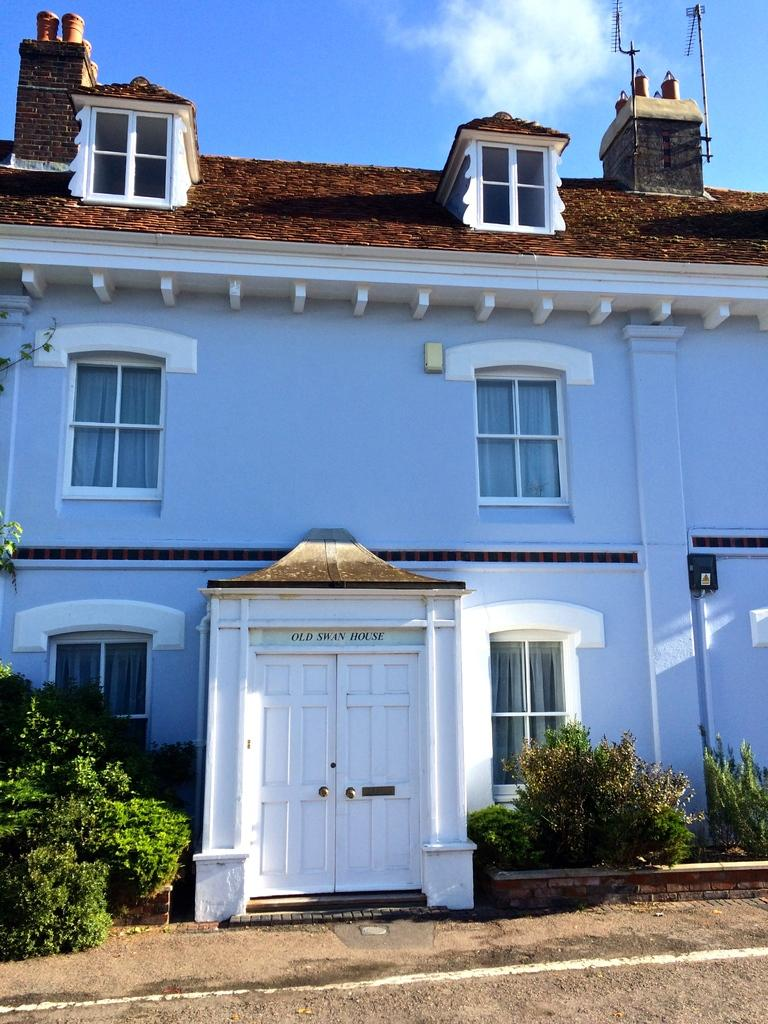What is the main structure in the image? There is a big building in the image. What can be seen on the building's entrance? The building has a white door. What type of windows does the building have? The building has glass windows. What is present in front of the building? There are many plants in front of the building. What type of bells can be heard ringing in the image? There are no bells present in the image, and therefore no sound can be heard. 